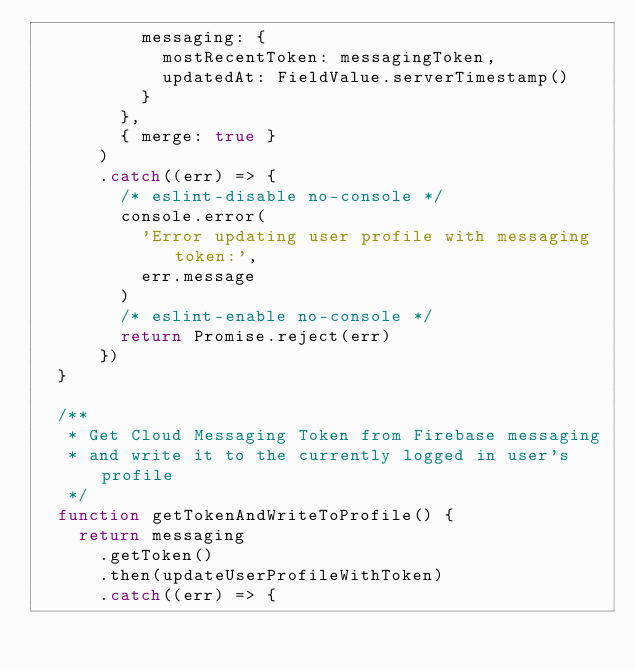<code> <loc_0><loc_0><loc_500><loc_500><_JavaScript_>          messaging: {
            mostRecentToken: messagingToken,
            updatedAt: FieldValue.serverTimestamp()
          }
        },
        { merge: true }
      )
      .catch((err) => {
        /* eslint-disable no-console */
        console.error(
          'Error updating user profile with messaging token:',
          err.message
        )
        /* eslint-enable no-console */
        return Promise.reject(err)
      })
  }

  /**
   * Get Cloud Messaging Token from Firebase messaging
   * and write it to the currently logged in user's profile
   */
  function getTokenAndWriteToProfile() {
    return messaging
      .getToken()
      .then(updateUserProfileWithToken)
      .catch((err) => {</code> 